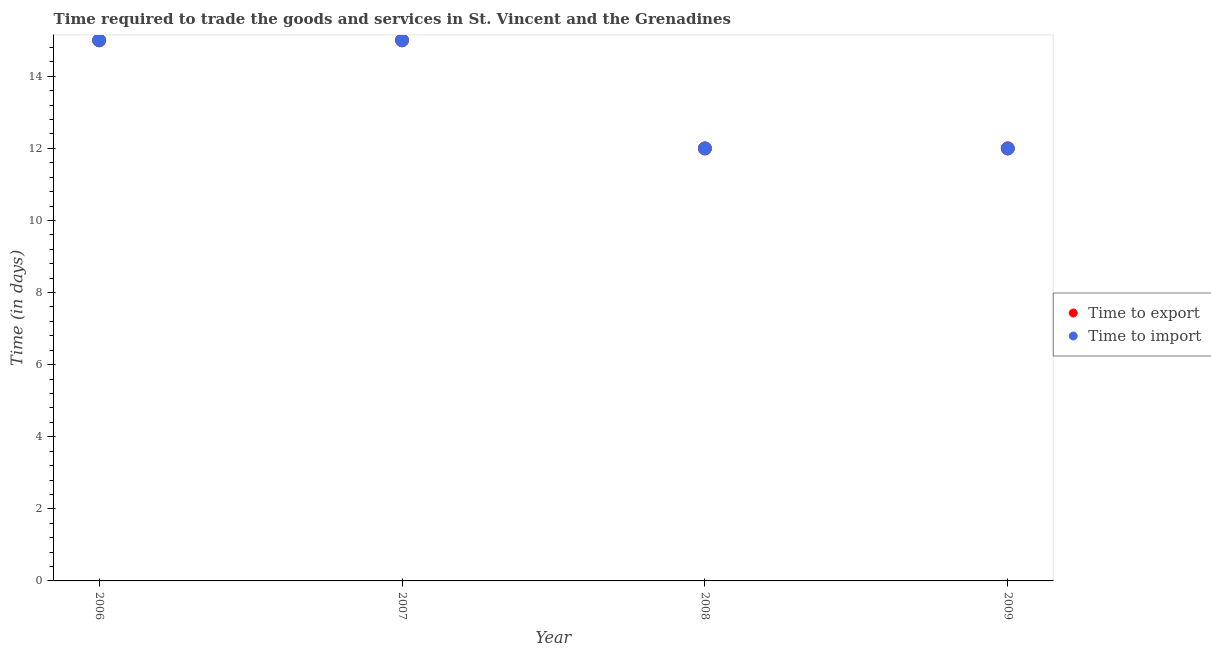What is the time to import in 2006?
Keep it short and to the point. 15. Across all years, what is the maximum time to import?
Your answer should be very brief. 15. Across all years, what is the minimum time to import?
Ensure brevity in your answer.  12. What is the total time to import in the graph?
Your answer should be compact. 54. What is the difference between the time to import in 2009 and the time to export in 2008?
Keep it short and to the point. 0. Is the difference between the time to export in 2006 and 2008 greater than the difference between the time to import in 2006 and 2008?
Offer a very short reply. No. What is the difference between the highest and the second highest time to import?
Make the answer very short. 0. What is the difference between the highest and the lowest time to import?
Keep it short and to the point. 3. Is the sum of the time to import in 2006 and 2009 greater than the maximum time to export across all years?
Make the answer very short. Yes. Does the time to export monotonically increase over the years?
Provide a succinct answer. No. How many years are there in the graph?
Offer a very short reply. 4. What is the difference between two consecutive major ticks on the Y-axis?
Make the answer very short. 2. Does the graph contain any zero values?
Your response must be concise. No. Where does the legend appear in the graph?
Ensure brevity in your answer.  Center right. How many legend labels are there?
Provide a succinct answer. 2. What is the title of the graph?
Your answer should be compact. Time required to trade the goods and services in St. Vincent and the Grenadines. Does "Mineral" appear as one of the legend labels in the graph?
Keep it short and to the point. No. What is the label or title of the Y-axis?
Provide a short and direct response. Time (in days). What is the Time (in days) of Time to import in 2006?
Offer a very short reply. 15. What is the Time (in days) of Time to export in 2007?
Offer a very short reply. 15. What is the Time (in days) of Time to import in 2007?
Your answer should be compact. 15. What is the Time (in days) in Time to import in 2008?
Give a very brief answer. 12. What is the Time (in days) in Time to import in 2009?
Keep it short and to the point. 12. Across all years, what is the minimum Time (in days) of Time to export?
Offer a terse response. 12. What is the total Time (in days) in Time to export in the graph?
Keep it short and to the point. 54. What is the difference between the Time (in days) of Time to export in 2006 and that in 2007?
Provide a succinct answer. 0. What is the difference between the Time (in days) in Time to import in 2006 and that in 2007?
Keep it short and to the point. 0. What is the difference between the Time (in days) in Time to export in 2006 and that in 2008?
Provide a short and direct response. 3. What is the difference between the Time (in days) of Time to import in 2006 and that in 2009?
Ensure brevity in your answer.  3. What is the difference between the Time (in days) in Time to import in 2007 and that in 2009?
Make the answer very short. 3. What is the difference between the Time (in days) of Time to export in 2008 and that in 2009?
Provide a succinct answer. 0. What is the difference between the Time (in days) of Time to import in 2008 and that in 2009?
Provide a short and direct response. 0. What is the difference between the Time (in days) of Time to export in 2006 and the Time (in days) of Time to import in 2007?
Your answer should be very brief. 0. What is the difference between the Time (in days) of Time to export in 2006 and the Time (in days) of Time to import in 2008?
Offer a terse response. 3. What is the difference between the Time (in days) of Time to export in 2008 and the Time (in days) of Time to import in 2009?
Offer a very short reply. 0. What is the average Time (in days) of Time to export per year?
Provide a succinct answer. 13.5. What is the average Time (in days) of Time to import per year?
Your response must be concise. 13.5. In the year 2006, what is the difference between the Time (in days) in Time to export and Time (in days) in Time to import?
Provide a short and direct response. 0. In the year 2007, what is the difference between the Time (in days) in Time to export and Time (in days) in Time to import?
Ensure brevity in your answer.  0. What is the ratio of the Time (in days) in Time to export in 2006 to that in 2007?
Your answer should be very brief. 1. What is the ratio of the Time (in days) of Time to import in 2006 to that in 2007?
Offer a terse response. 1. What is the ratio of the Time (in days) in Time to import in 2006 to that in 2008?
Provide a short and direct response. 1.25. What is the ratio of the Time (in days) of Time to export in 2006 to that in 2009?
Offer a terse response. 1.25. What is the ratio of the Time (in days) in Time to import in 2006 to that in 2009?
Keep it short and to the point. 1.25. What is the ratio of the Time (in days) in Time to export in 2007 to that in 2008?
Provide a short and direct response. 1.25. What is the ratio of the Time (in days) of Time to import in 2007 to that in 2008?
Your answer should be compact. 1.25. What is the ratio of the Time (in days) of Time to export in 2007 to that in 2009?
Your answer should be very brief. 1.25. What is the difference between the highest and the second highest Time (in days) of Time to export?
Provide a short and direct response. 0. What is the difference between the highest and the second highest Time (in days) in Time to import?
Provide a succinct answer. 0. What is the difference between the highest and the lowest Time (in days) in Time to export?
Give a very brief answer. 3. What is the difference between the highest and the lowest Time (in days) of Time to import?
Provide a short and direct response. 3. 